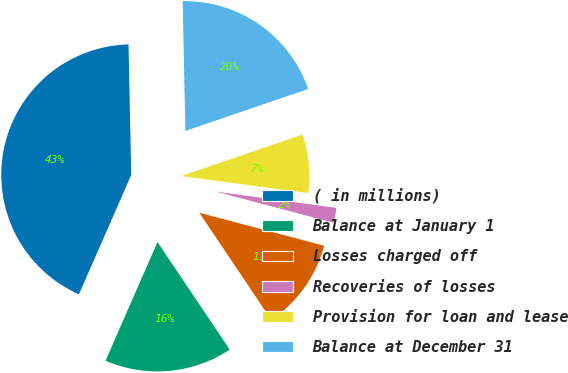Convert chart. <chart><loc_0><loc_0><loc_500><loc_500><pie_chart><fcel>( in millions)<fcel>Balance at January 1<fcel>Losses charged off<fcel>Recoveries of losses<fcel>Provision for loan and lease<fcel>Balance at December 31<nl><fcel>43.1%<fcel>15.98%<fcel>11.48%<fcel>1.98%<fcel>7.37%<fcel>20.1%<nl></chart> 